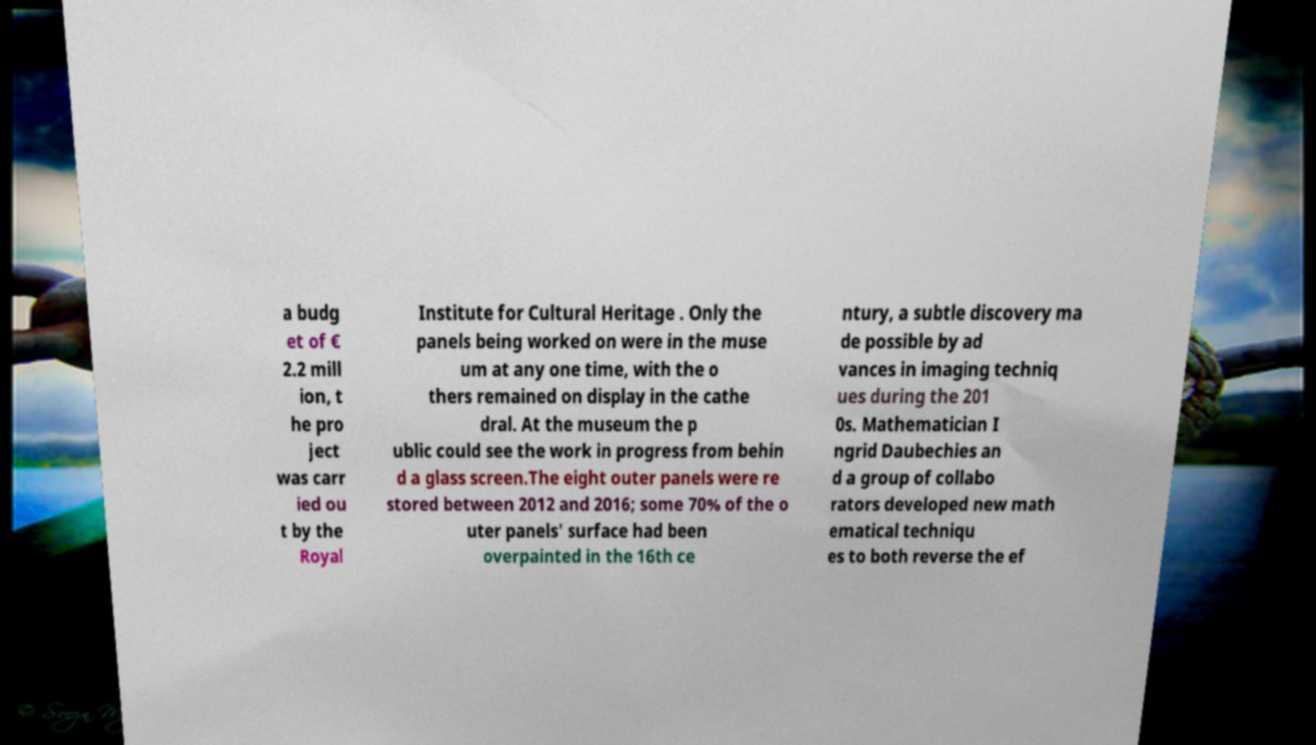Can you read and provide the text displayed in the image?This photo seems to have some interesting text. Can you extract and type it out for me? a budg et of € 2.2 mill ion, t he pro ject was carr ied ou t by the Royal Institute for Cultural Heritage . Only the panels being worked on were in the muse um at any one time, with the o thers remained on display in the cathe dral. At the museum the p ublic could see the work in progress from behin d a glass screen.The eight outer panels were re stored between 2012 and 2016; some 70% of the o uter panels' surface had been overpainted in the 16th ce ntury, a subtle discovery ma de possible by ad vances in imaging techniq ues during the 201 0s. Mathematician I ngrid Daubechies an d a group of collabo rators developed new math ematical techniqu es to both reverse the ef 